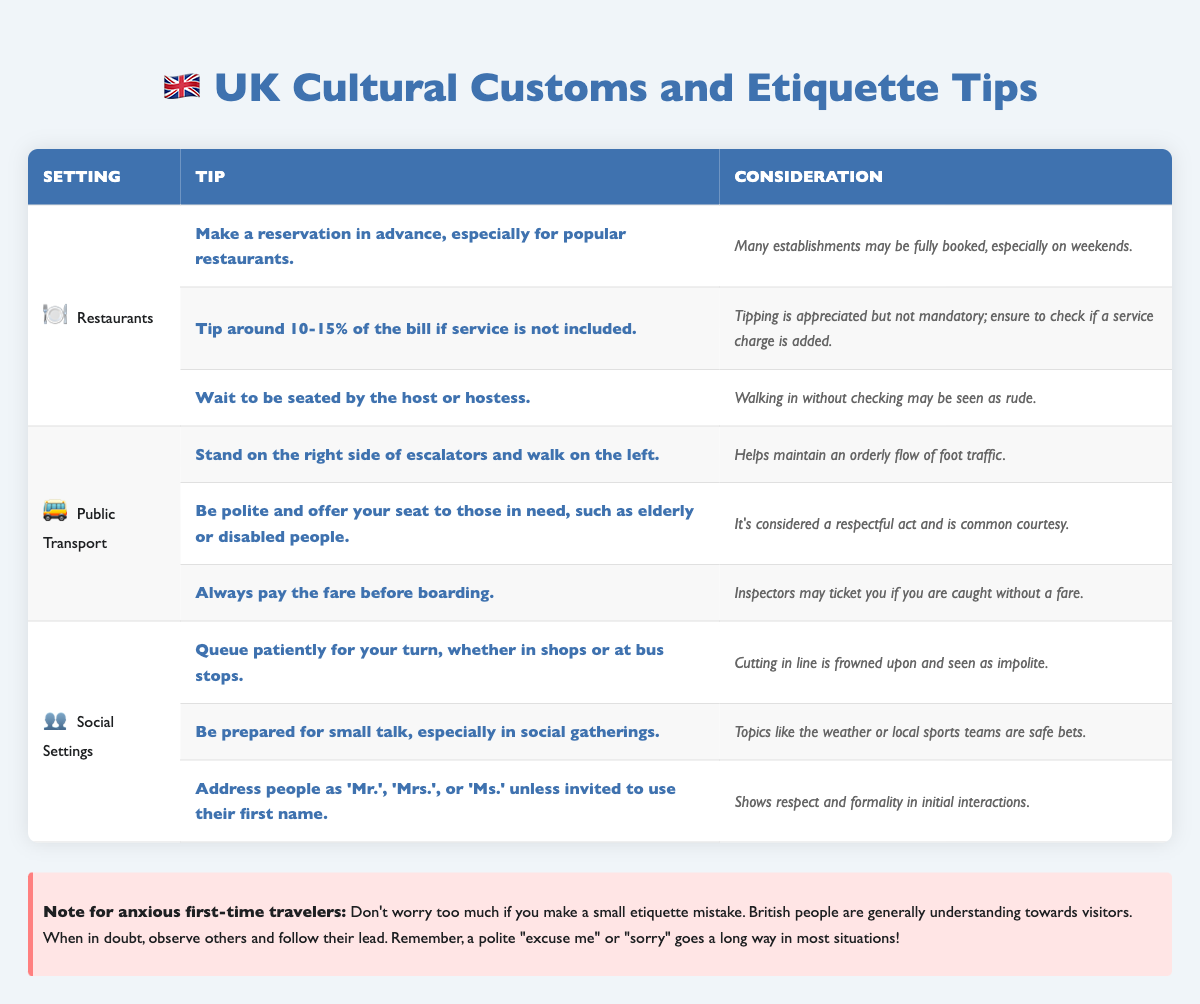What is the tip percentage typically suggested in restaurants? The table indicates that a tip of around 10-15% of the bill is suggested if service is not included.
Answer: 10-15% What should you do when entering a restaurant? According to the table, you should wait to be seated by the host or hostess, as walking in without checking may be seen as rude.
Answer: Wait to be seated Is it considered polite to offer your seat on public transport? Yes, it is considered a respectful act to offer your seat to those in need, such as the elderly or disabled people.
Answer: Yes What are two tips for social settings in the UK? The table lists two tips: queue patiently for your turn and be prepared for small talk.
Answer: Queue patiently and be prepared for small talk How many tips are provided for public transport etiquette? The table provides three tips for public transport etiquette. You can see that there are three distinct entries under the "Public Transport" section.
Answer: Three tips What is the first consideration mentioned regarding restaurant reservations? The consideration states that many establishments may be fully booked, especially on weekends.
Answer: Many establishments may be fully booked on weekends In what situations is it more appropriate to address someone with a title rather than their first name? It’s appropriate to address people as 'Mr.', 'Mrs.', or 'Ms.' unless invited to use their first name, according to the etiquette tips.
Answer: Initial interactions What happens if you don't pay the fare before boarding public transport? The consideration states that inspectors may ticket you if you are caught without a fare, indicating a strict enforcement of the payment rule.
Answer: You may be ticketed Which setting emphasizes the importance of queuing? The social settings section emphasizes the importance of queuing patiently for your turn, indicating it’s frowned upon to cut in line.
Answer: Social settings What are safe topics for small talk during social gatherings? The table suggests that topics like the weather or local sports teams are safe bets for small talk in social gatherings.
Answer: Weather or local sports teams 